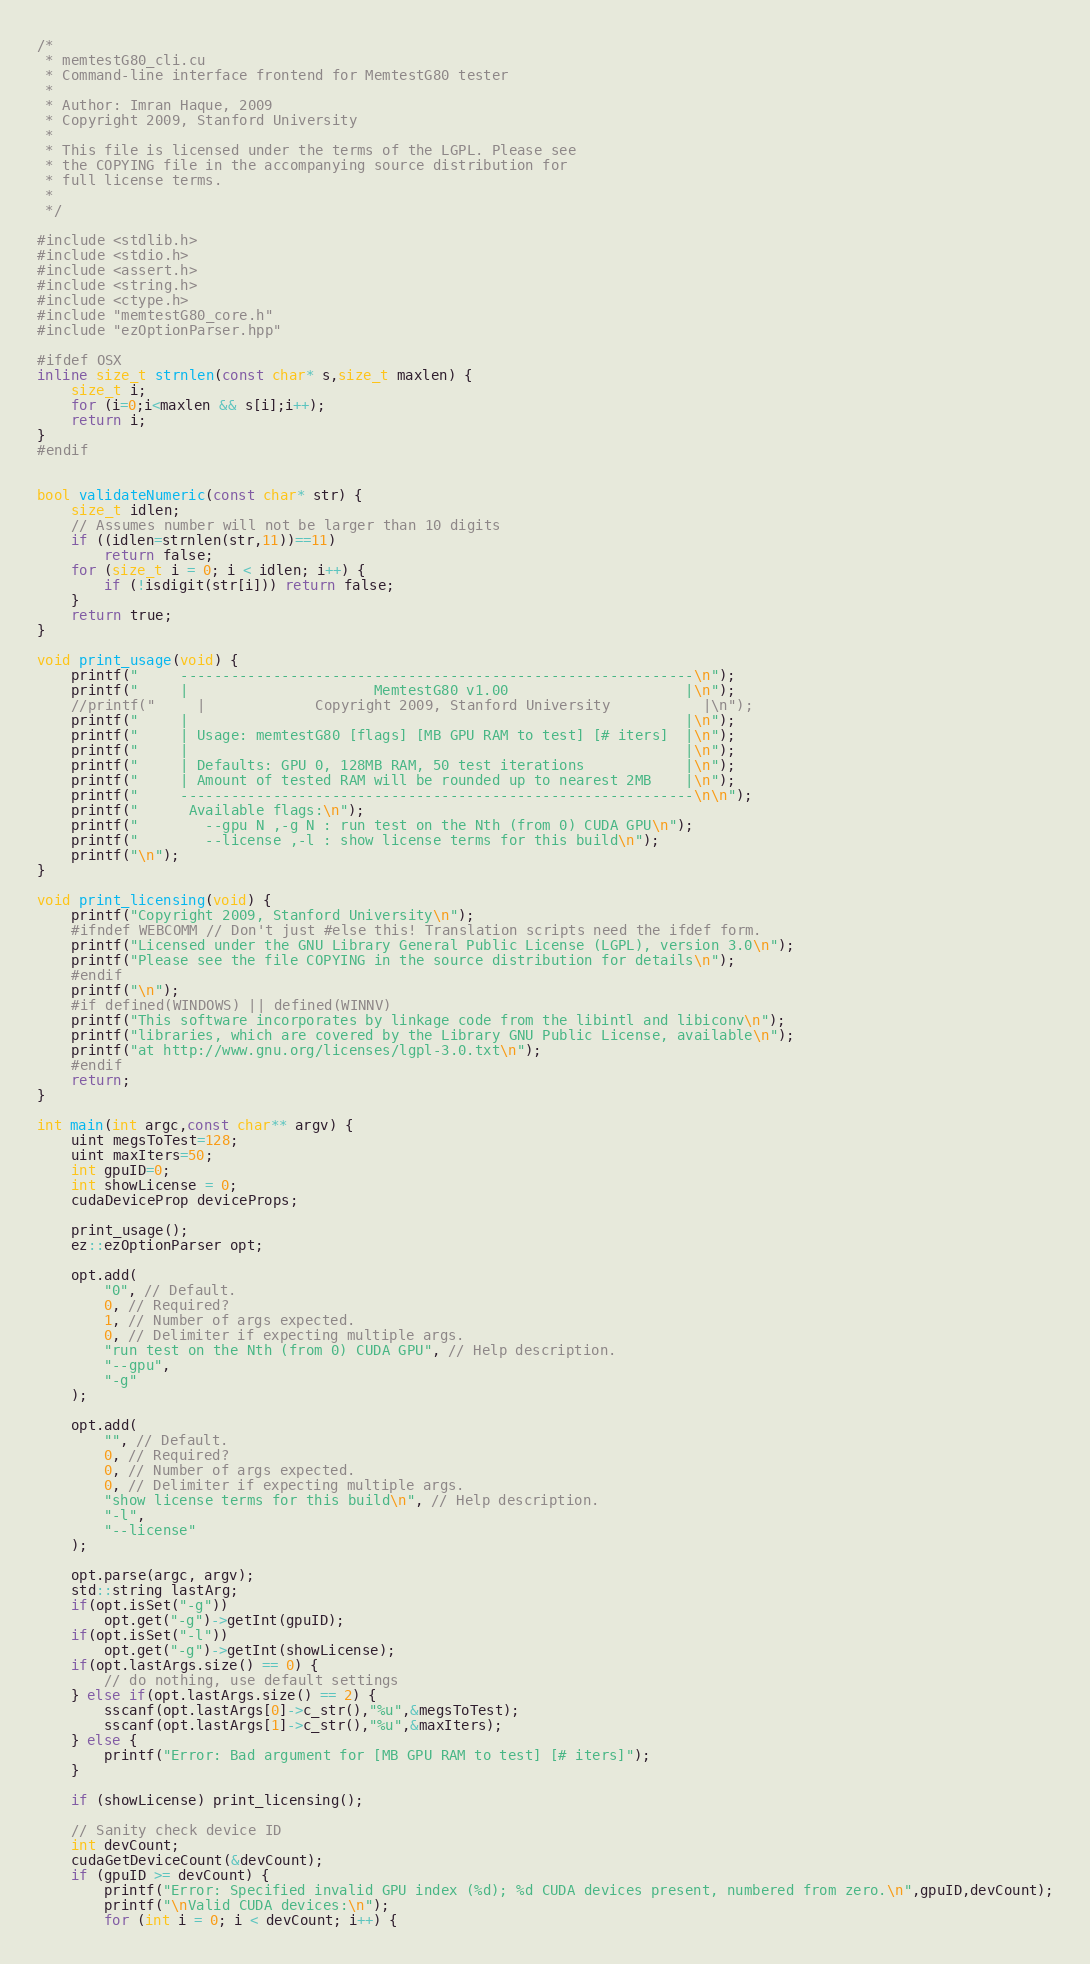Convert code to text. <code><loc_0><loc_0><loc_500><loc_500><_Cuda_>/*
 * memtestG80_cli.cu
 * Command-line interface frontend for MemtestG80 tester
 *
 * Author: Imran Haque, 2009
 * Copyright 2009, Stanford University
 *
 * This file is licensed under the terms of the LGPL. Please see
 * the COPYING file in the accompanying source distribution for
 * full license terms.
 *
 */

#include <stdlib.h>
#include <stdio.h>
#include <assert.h>
#include <string.h>
#include <ctype.h>
#include "memtestG80_core.h"
#include "ezOptionParser.hpp"

#ifdef OSX
inline size_t strnlen(const char* s,size_t maxlen) {
    size_t i;
    for (i=0;i<maxlen && s[i];i++);
    return i;
}
#endif


bool validateNumeric(const char* str) {
    size_t idlen;
    // Assumes number will not be larger than 10 digits
    if ((idlen=strnlen(str,11))==11)
        return false;
    for (size_t i = 0; i < idlen; i++) {
        if (!isdigit(str[i])) return false;
    }
    return true;
}

void print_usage(void) {
    printf("     -------------------------------------------------------------\n");
    printf("     |                      MemtestG80 v1.00                     |\n");
    //printf("     |             Copyright 2009, Stanford University           |\n");
    printf("     |                                                           |\n");
    printf("     | Usage: memtestG80 [flags] [MB GPU RAM to test] [# iters]  |\n");
    printf("     |                                                           |\n");
    printf("     | Defaults: GPU 0, 128MB RAM, 50 test iterations            |\n");
    printf("     | Amount of tested RAM will be rounded up to nearest 2MB    |\n");
    printf("     -------------------------------------------------------------\n\n");
    printf("      Available flags:\n");
    printf("        --gpu N ,-g N : run test on the Nth (from 0) CUDA GPU\n");
    printf("        --license ,-l : show license terms for this build\n");
    printf("\n");
}

void print_licensing(void) {
    printf("Copyright 2009, Stanford University\n");
    #ifndef WEBCOMM // Don't just #else this! Translation scripts need the ifdef form.
    printf("Licensed under the GNU Library General Public License (LGPL), version 3.0\n");
    printf("Please see the file COPYING in the source distribution for details\n");
    #endif
    printf("\n");
    #if defined(WINDOWS) || defined(WINNV)
    printf("This software incorporates by linkage code from the libintl and libiconv\n");
    printf("libraries, which are covered by the Library GNU Public License, available\n");
    printf("at http://www.gnu.org/licenses/lgpl-3.0.txt\n");
    #endif
    return;
}

int main(int argc,const char** argv) {
    uint megsToTest=128;
    uint maxIters=50;
    int gpuID=0;
    int showLicense = 0;
    cudaDeviceProp deviceProps;

    print_usage(); 
    ez::ezOptionParser opt;

    opt.add(
        "0", // Default.
        0, // Required?
        1, // Number of args expected.
        0, // Delimiter if expecting multiple args.
        "run test on the Nth (from 0) CUDA GPU", // Help description.
        "--gpu",
        "-g"
    );

    opt.add(
        "", // Default.
        0, // Required?
        0, // Number of args expected.
        0, // Delimiter if expecting multiple args.
        "show license terms for this build\n", // Help description.
        "-l",
        "--license"
    );

    opt.parse(argc, argv);
    std::string lastArg;
    if(opt.isSet("-g"))
        opt.get("-g")->getInt(gpuID);
    if(opt.isSet("-l"))
        opt.get("-g")->getInt(showLicense);
    if(opt.lastArgs.size() == 0) {
        // do nothing, use default settings
    } else if(opt.lastArgs.size() == 2) {
        sscanf(opt.lastArgs[0]->c_str(),"%u",&megsToTest);
        sscanf(opt.lastArgs[1]->c_str(),"%u",&maxIters);
    } else {
        printf("Error: Bad argument for [MB GPU RAM to test] [# iters]");
    }

    if (showLicense) print_licensing();
    
    // Sanity check device ID
    int devCount;
    cudaGetDeviceCount(&devCount);
    if (gpuID >= devCount) {
        printf("Error: Specified invalid GPU index (%d); %d CUDA devices present, numbered from zero.\n",gpuID,devCount);
        printf("\nValid CUDA devices:\n");
        for (int i = 0; i < devCount; i++) {</code> 